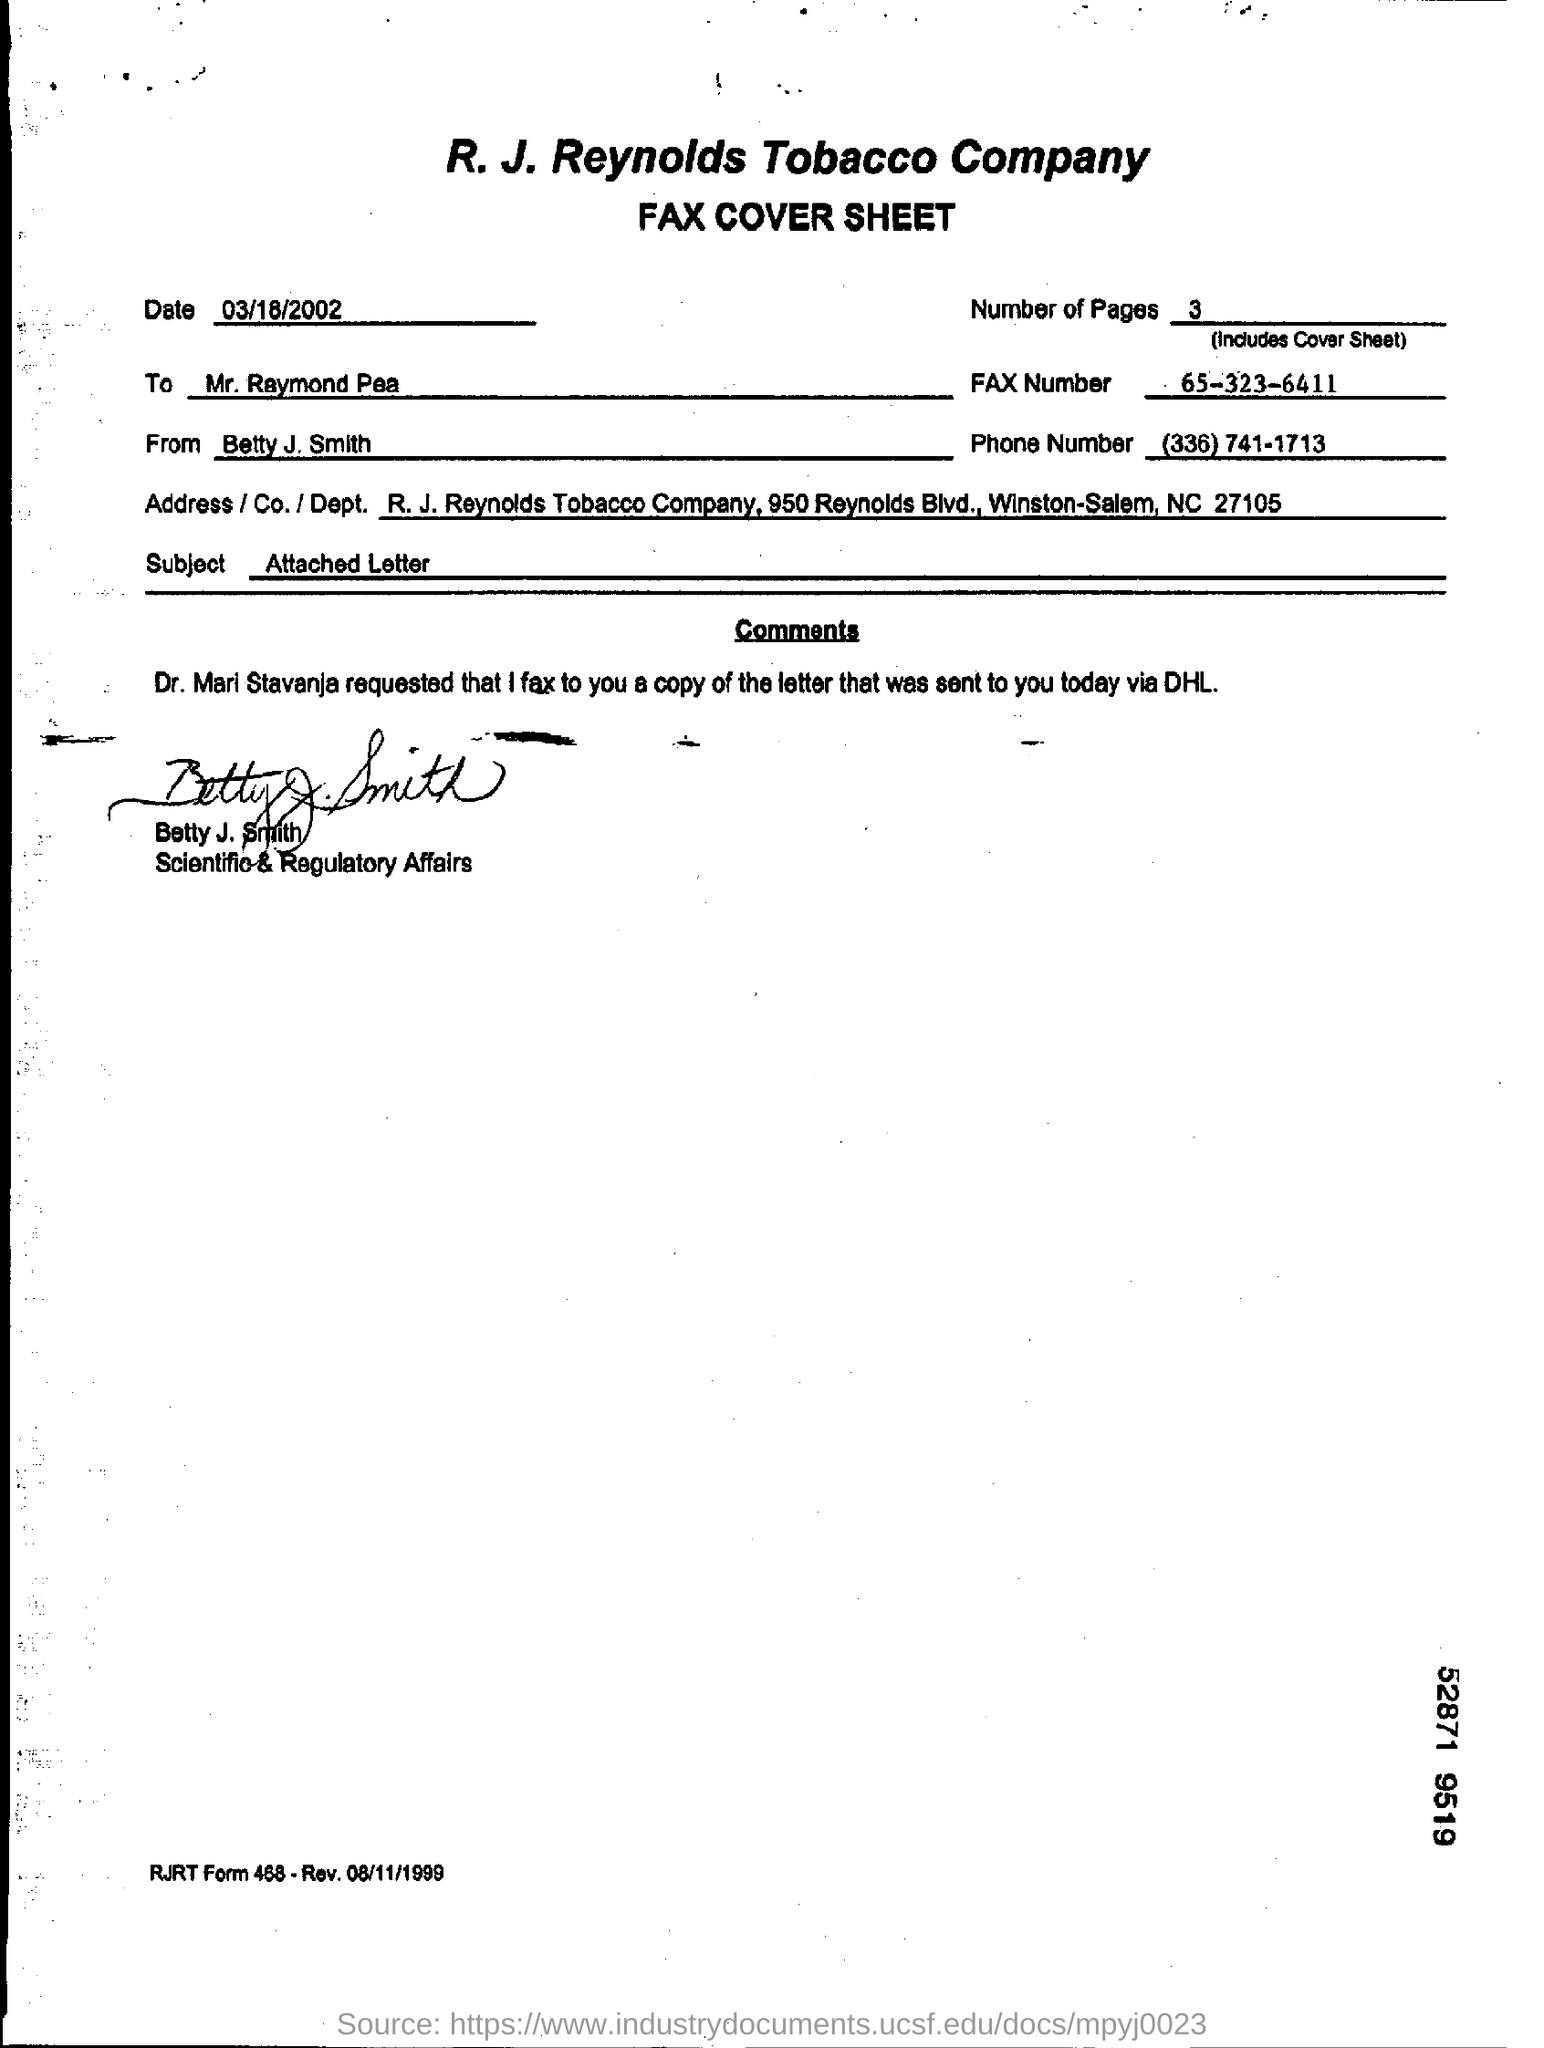When is the fax cover sheet dated?
Ensure brevity in your answer.  03/18/2002. How many pages are there including cover sheet?
Your answer should be compact. 3. What is the Fax number given?
Your answer should be compact. 65-323-6411. What is written on the subject line?
Your answer should be very brief. Attached Letter. 